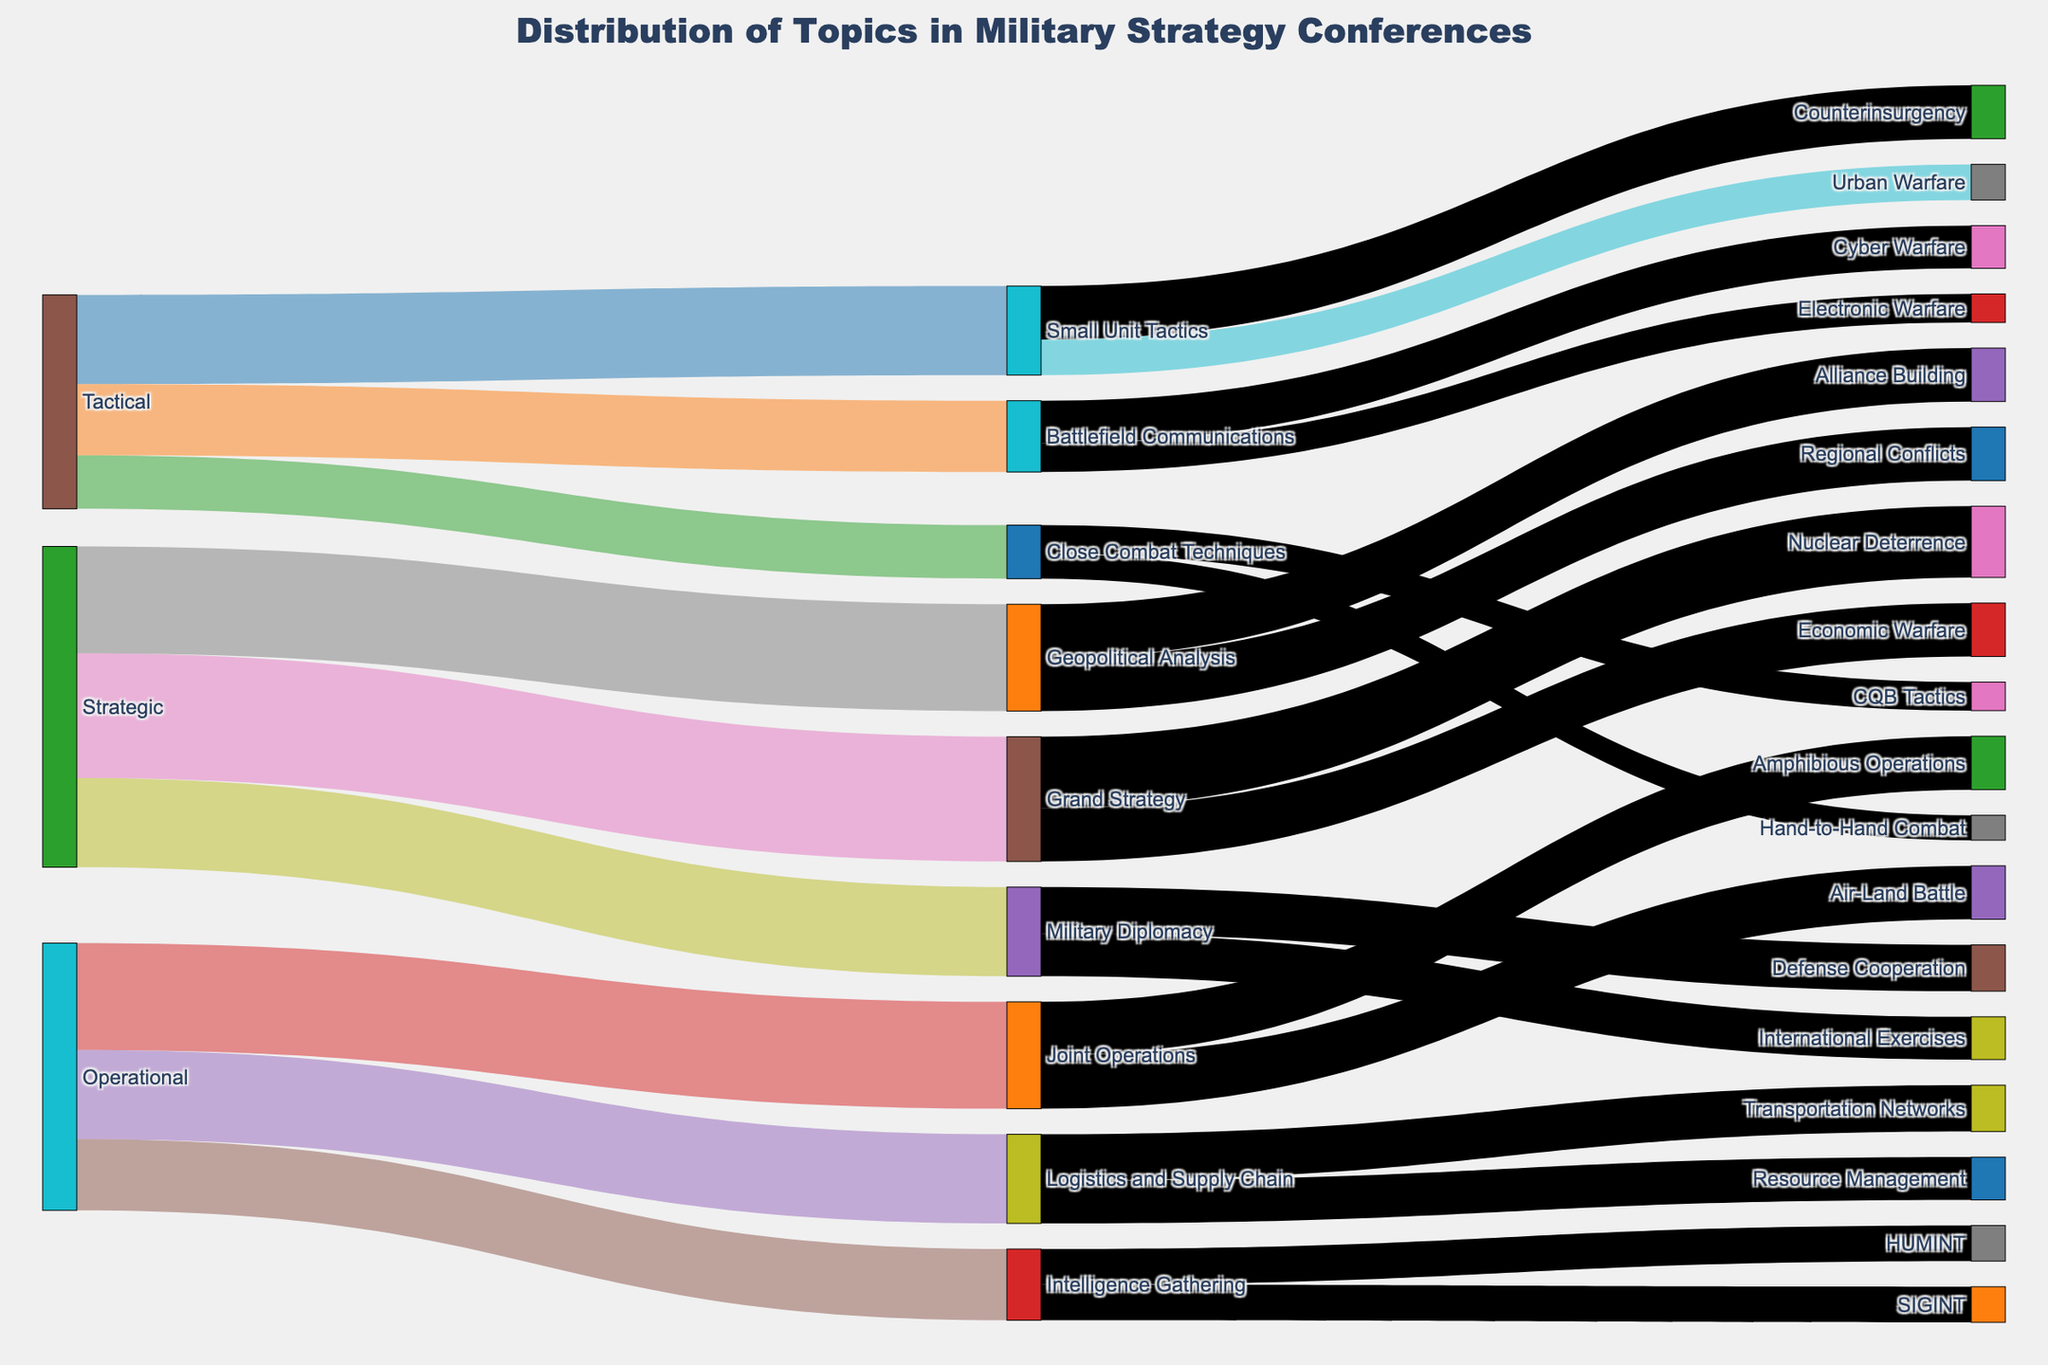What is the title of the figure? The title is usually placed at the top center of the figure. In this case, it reads "Distribution of Topics in Military Strategy Conferences".
Answer: Distribution of Topics in Military Strategy Conferences What are the three main levels of topics covered in the figure? By examining the initial nodes at the highest level of the Sankey diagram, we can see the three categories are Tactical, Operational, and Strategic.
Answer: Tactical, Operational, Strategic Which tactical topic has the highest value? Checking the values connected to Tactical, we find that Small Unit Tactics has the highest value of 25.
Answer: Small Unit Tactics How is the value distributed among the subtopics under Small Unit Tactics? The subtopics under Small Unit Tactics are Urban Warfare and Counterinsurgency, with values of 10 and 15 respectively. Summing these gives us the total value for Small Unit Tactics as divided into 10 and 15.
Answer: 10 for Urban Warfare, 15 for Counterinsurgency Which operational topic has the least number of subtopics? Checking the targets linked to Joint Operations, Logistics and Supply Chain, and Intelligence Gathering, we see that the Operational topic with the fewest subtopics is Intelligence Gathering, as it has only two subtopics: SIGINT and HUMINT.
Answer: Intelligence Gathering How does the value of Grand Strategy compare to Geopolitical Analysis? From the diagram, Grand Strategy has a value of 35, while Geopolitical Analysis has a value of 30. Thus, Grand Strategy has a higher value by 5.
Answer: Grand Strategy has 5 more What is the combined value of all subtopics under Tactical? Adding the values of Small Unit Tactics (25), Battlefield Communications (20), and Close Combat Techniques (15) gives us a combined total of 25 + 20 + 15 = 60.
Answer: 60 Which strategic subtopic has the highest value? The subtopic involves Grand Strategy, Geopolitical Analysis, and Military Diplomacy. Grand Strategy has the highest value at 35.
Answer: Grand Strategy How does the value of Logistics and Supply Chain compare to Battlefield Communications? Logistics and Supply Chain has a value of 25, whereas Battlefield Communications has a value of 20, indicating Logistics and Supply Chain has a higher value by 5.
Answer: Logistics and Supply Chain is 5 more than Battlefield Communications What are the color characteristics of the nodes and links in the diagram? The nodes are colored based on a predefined palette, and the links connecting these nodes are somewhat transparent versions of those node colors. Each node label and its corresponding lines are distinct colors made from the color palette provided.
Answer: Nodes use a distinct color palette, links have transparent colors 